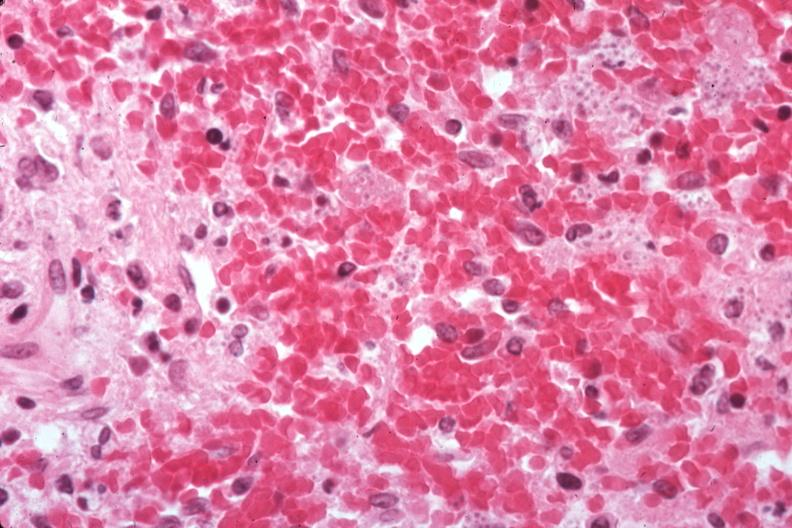what is present?
Answer the question using a single word or phrase. Spleen 